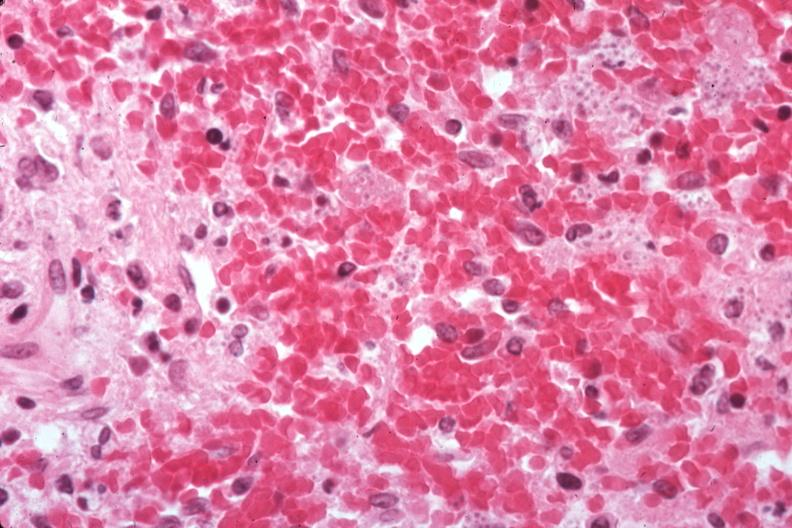what is present?
Answer the question using a single word or phrase. Spleen 